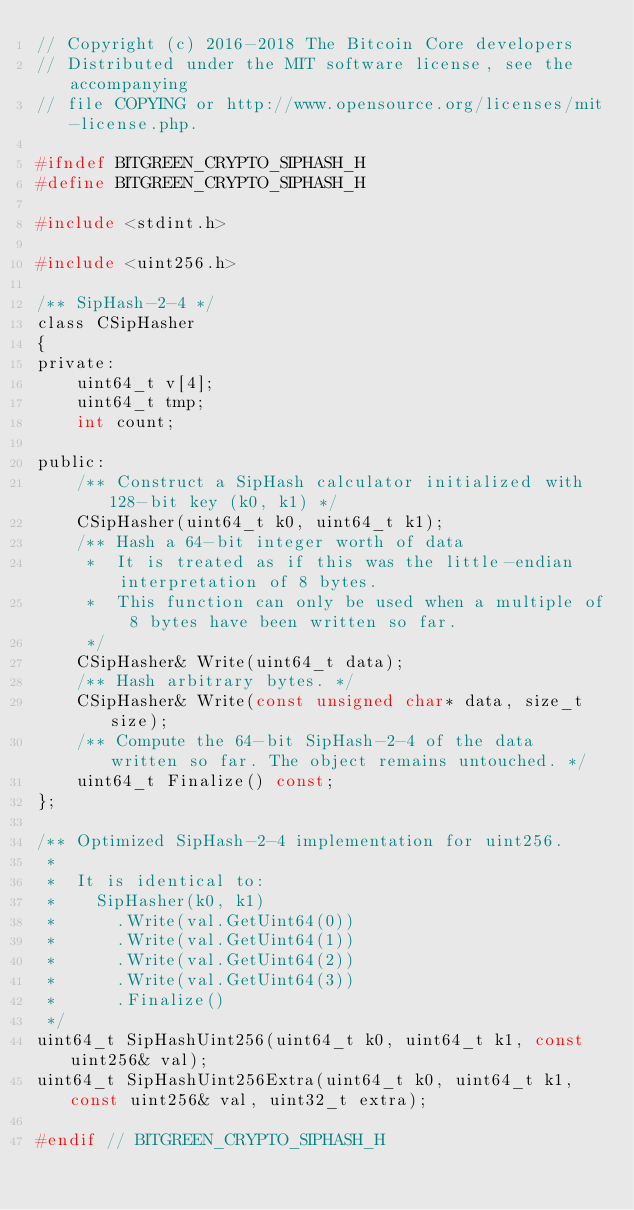Convert code to text. <code><loc_0><loc_0><loc_500><loc_500><_C_>// Copyright (c) 2016-2018 The Bitcoin Core developers
// Distributed under the MIT software license, see the accompanying
// file COPYING or http://www.opensource.org/licenses/mit-license.php.

#ifndef BITGREEN_CRYPTO_SIPHASH_H
#define BITGREEN_CRYPTO_SIPHASH_H

#include <stdint.h>

#include <uint256.h>

/** SipHash-2-4 */
class CSipHasher
{
private:
    uint64_t v[4];
    uint64_t tmp;
    int count;

public:
    /** Construct a SipHash calculator initialized with 128-bit key (k0, k1) */
    CSipHasher(uint64_t k0, uint64_t k1);
    /** Hash a 64-bit integer worth of data
     *  It is treated as if this was the little-endian interpretation of 8 bytes.
     *  This function can only be used when a multiple of 8 bytes have been written so far.
     */
    CSipHasher& Write(uint64_t data);
    /** Hash arbitrary bytes. */
    CSipHasher& Write(const unsigned char* data, size_t size);
    /** Compute the 64-bit SipHash-2-4 of the data written so far. The object remains untouched. */
    uint64_t Finalize() const;
};

/** Optimized SipHash-2-4 implementation for uint256.
 *
 *  It is identical to:
 *    SipHasher(k0, k1)
 *      .Write(val.GetUint64(0))
 *      .Write(val.GetUint64(1))
 *      .Write(val.GetUint64(2))
 *      .Write(val.GetUint64(3))
 *      .Finalize()
 */
uint64_t SipHashUint256(uint64_t k0, uint64_t k1, const uint256& val);
uint64_t SipHashUint256Extra(uint64_t k0, uint64_t k1, const uint256& val, uint32_t extra);

#endif // BITGREEN_CRYPTO_SIPHASH_H
</code> 